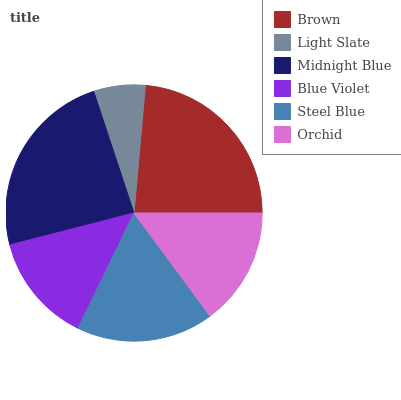Is Light Slate the minimum?
Answer yes or no. Yes. Is Midnight Blue the maximum?
Answer yes or no. Yes. Is Midnight Blue the minimum?
Answer yes or no. No. Is Light Slate the maximum?
Answer yes or no. No. Is Midnight Blue greater than Light Slate?
Answer yes or no. Yes. Is Light Slate less than Midnight Blue?
Answer yes or no. Yes. Is Light Slate greater than Midnight Blue?
Answer yes or no. No. Is Midnight Blue less than Light Slate?
Answer yes or no. No. Is Steel Blue the high median?
Answer yes or no. Yes. Is Orchid the low median?
Answer yes or no. Yes. Is Blue Violet the high median?
Answer yes or no. No. Is Blue Violet the low median?
Answer yes or no. No. 